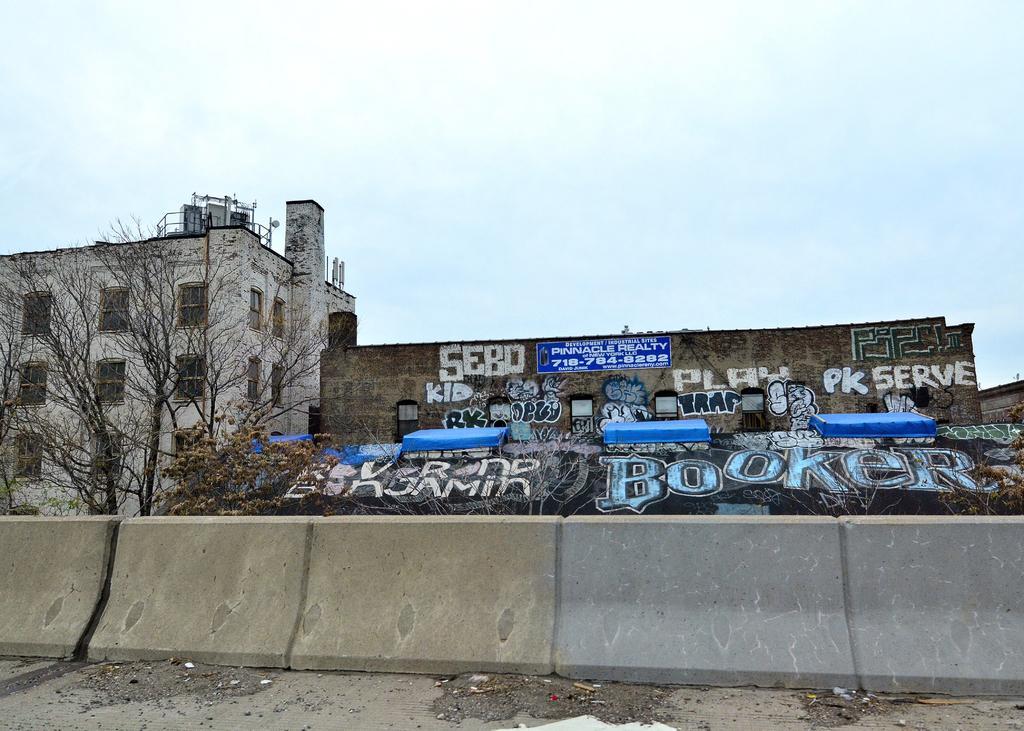How would you summarize this image in a sentence or two? In this image there is a wall, in the background there are trees, building on one building there is some text and the sky. 